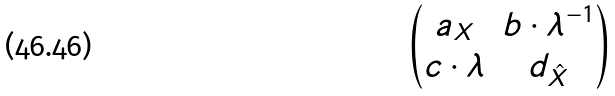<formula> <loc_0><loc_0><loc_500><loc_500>\begin{pmatrix} a _ { X } & b \cdot \lambda ^ { - 1 } \\ c \cdot \lambda & d _ { \hat { X } } \end{pmatrix}</formula> 